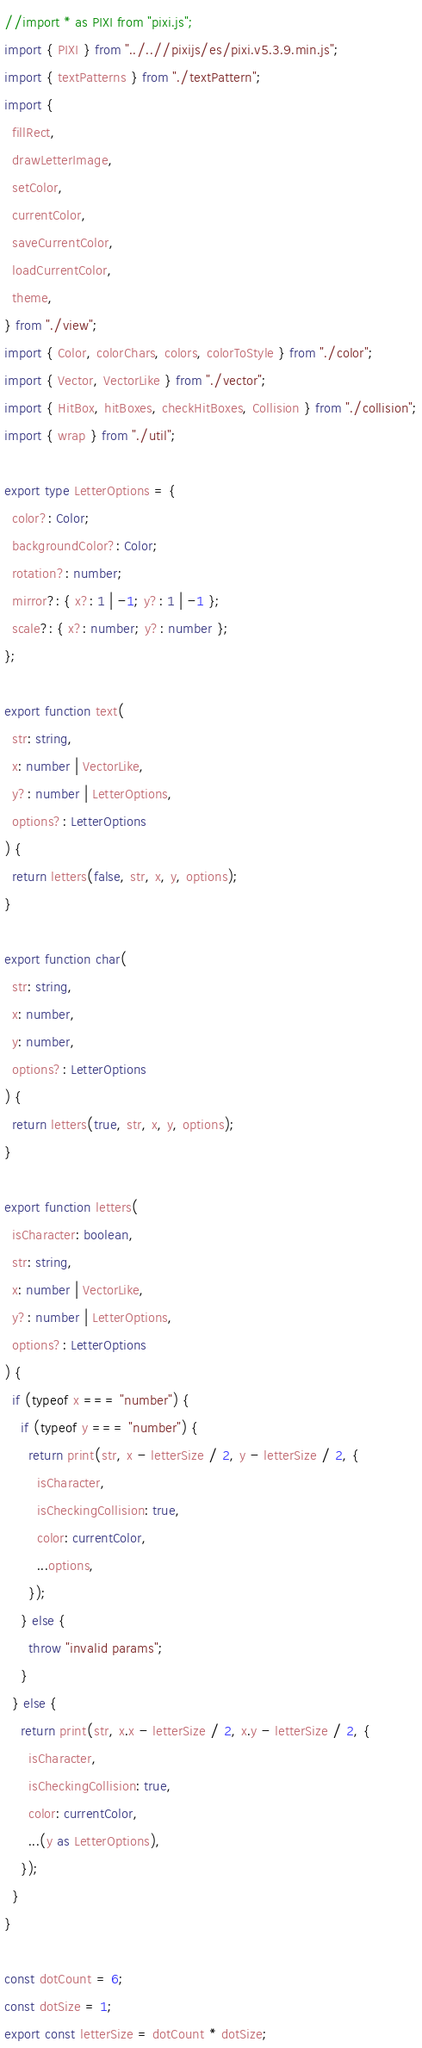<code> <loc_0><loc_0><loc_500><loc_500><_TypeScript_>//import * as PIXI from "pixi.js";
import { PIXI } from "../..//pixijs/es/pixi.v5.3.9.min.js";
import { textPatterns } from "./textPattern";
import {
  fillRect,
  drawLetterImage,
  setColor,
  currentColor,
  saveCurrentColor,
  loadCurrentColor,
  theme,
} from "./view";
import { Color, colorChars, colors, colorToStyle } from "./color";
import { Vector, VectorLike } from "./vector";
import { HitBox, hitBoxes, checkHitBoxes, Collision } from "./collision";
import { wrap } from "./util";

export type LetterOptions = {
  color?: Color;
  backgroundColor?: Color;
  rotation?: number;
  mirror?: { x?: 1 | -1; y?: 1 | -1 };
  scale?: { x?: number; y?: number };
};

export function text(
  str: string,
  x: number | VectorLike,
  y?: number | LetterOptions,
  options?: LetterOptions
) {
  return letters(false, str, x, y, options);
}

export function char(
  str: string,
  x: number,
  y: number,
  options?: LetterOptions
) {
  return letters(true, str, x, y, options);
}

export function letters(
  isCharacter: boolean,
  str: string,
  x: number | VectorLike,
  y?: number | LetterOptions,
  options?: LetterOptions
) {
  if (typeof x === "number") {
    if (typeof y === "number") {
      return print(str, x - letterSize / 2, y - letterSize / 2, {
        isCharacter,
        isCheckingCollision: true,
        color: currentColor,
        ...options,
      });
    } else {
      throw "invalid params";
    }
  } else {
    return print(str, x.x - letterSize / 2, x.y - letterSize / 2, {
      isCharacter,
      isCheckingCollision: true,
      color: currentColor,
      ...(y as LetterOptions),
    });
  }
}

const dotCount = 6;
const dotSize = 1;
export const letterSize = dotCount * dotSize;
</code> 